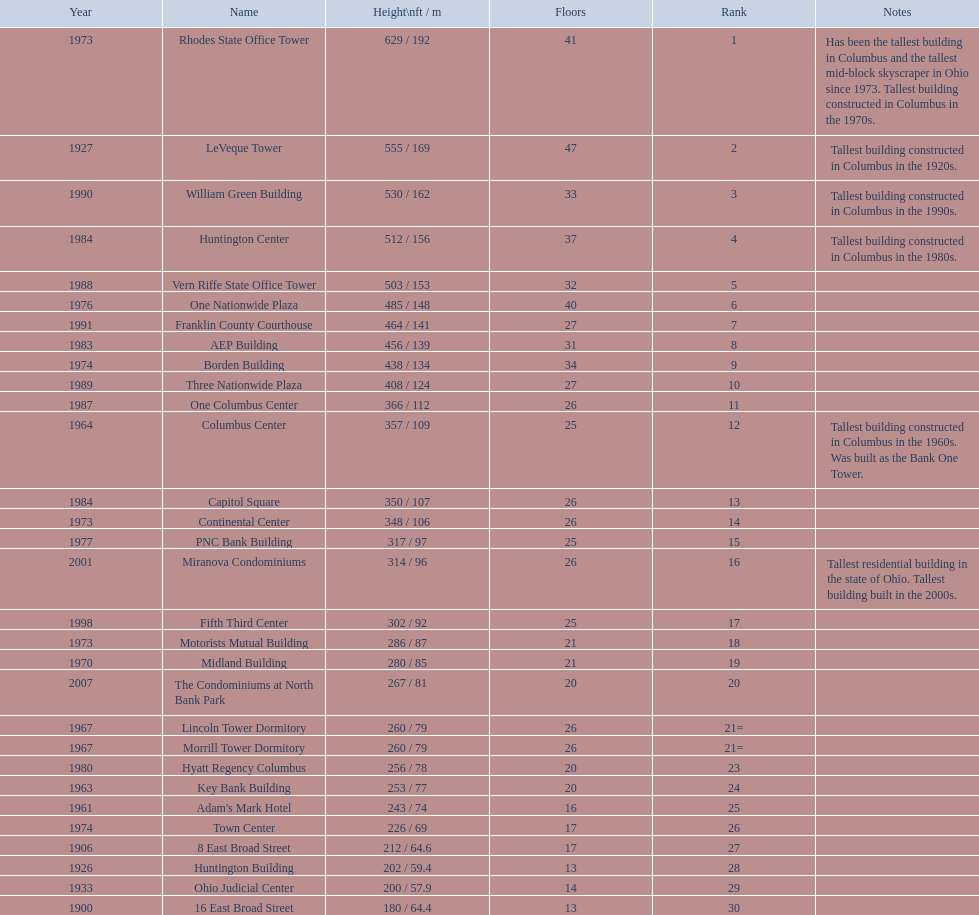Which of the tallest buildings in columbus, ohio were built in the 1980s? Huntington Center, Vern Riffe State Office Tower, AEP Building, Three Nationwide Plaza, One Columbus Center, Capitol Square, Hyatt Regency Columbus. Of these buildings, which have between 26 and 31 floors? AEP Building, Three Nationwide Plaza, One Columbus Center, Capitol Square. Of these buildings, which is the tallest? AEP Building. 